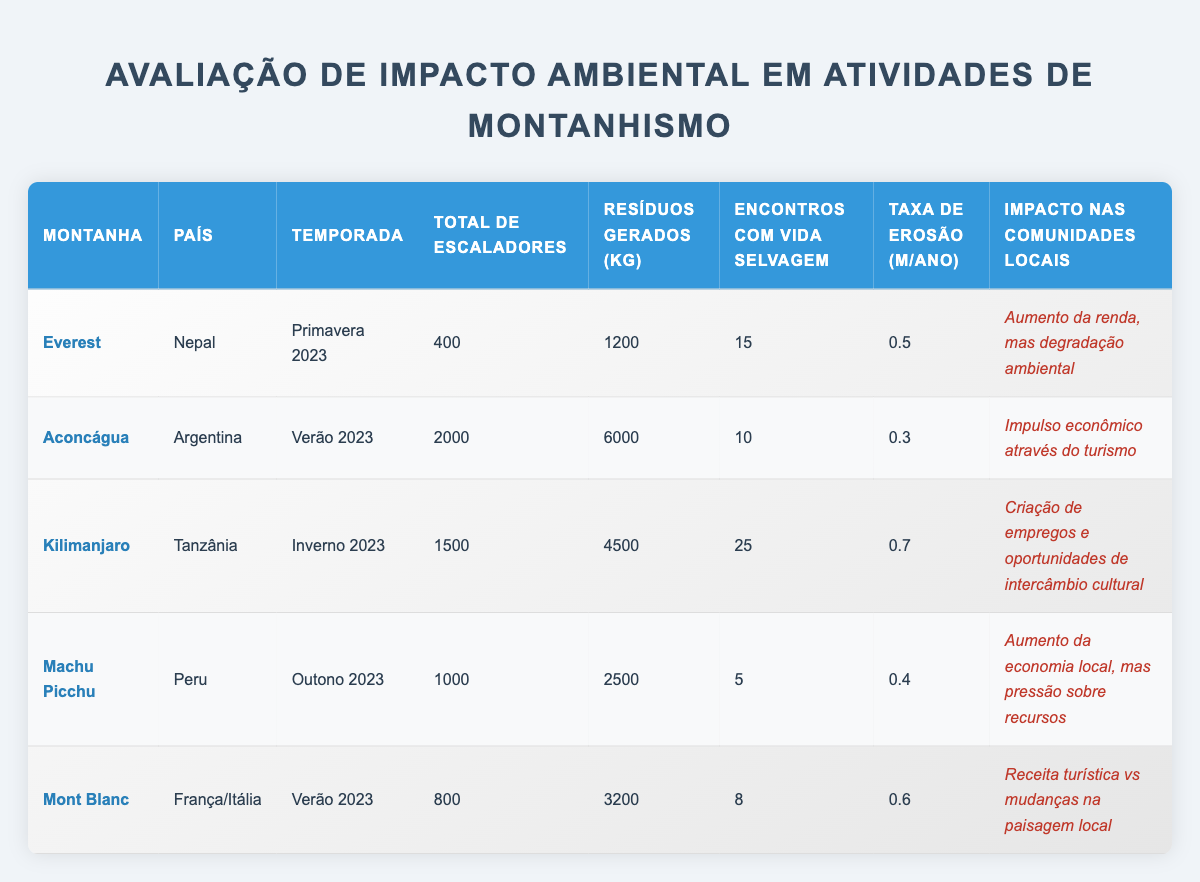What is the total waste generated by climbers on Mount Everest? The table lists that waste generated by climbers on Everest is 1200 kg.
Answer: 1200 kg What is the climbing season for Aconcagua? According to the table, the climbing season for Aconcagua is Summer 2023.
Answer: Summer 2023 How many climbers encountered wildlife on Kilimanjaro? The table indicates that there were 25 wildlife encounters for climbers on Kilimanjaro.
Answer: 25 What is the average erosion rate of the mountains listed in the table? The erosion rates are 0.5, 0.3, 0.7, 0.4, and 0.6 meters/year. Adding these gives 2.5 m/year, and dividing by 5 (the number of mountains) results in an average erosion rate of 0.5 m/year.
Answer: 0.5 m/year True or False: The impact on local communities for Kilimanjaro includes job creation. The table shows that the impact on local communities for Kilimanjaro is job creation and cultural exchange opportunities, which confirms this is true.
Answer: True Which mountain had the highest total climbers and what was that number? Upon reviewing the table, Aconcagua had the most climbers at 2000.
Answer: 2000 How much waste was generated by climbers on Machu Picchu compared to Kilimanjaro? Machu Picchu generated 2500 kg of waste, while Kilimanjaro generated 4500 kg. The difference is 4500 kg - 2500 kg = 2000 kg, with Kilimanjaro generating more waste.
Answer: Kilimanjaro generated 2000 kg more waste than Machu Picchu What is the impact on local communities for Mount Blanc? The table states that the impact on local communities for Mount Blanc involves tourist revenue versus local landscape changes.
Answer: Tourist revenue vs local landscape changes Which mountain has the lowest erosion rate and what is that rate? Reviewing the erosion rates, Aconcagua has the lowest rate of 0.3 m/year, compared to others such as Everest and Kilimanjaro.
Answer: Aconcagua, 0.3 m/year How many more climbers were on Aconcagua than on Mont Blanc? Aconcagua had 2000 climbers and Mont Blanc had 800 climbers. The difference is 2000 - 800 = 1200, indicating Aconcagua had 1200 more climbers.
Answer: 1200 climbers more 